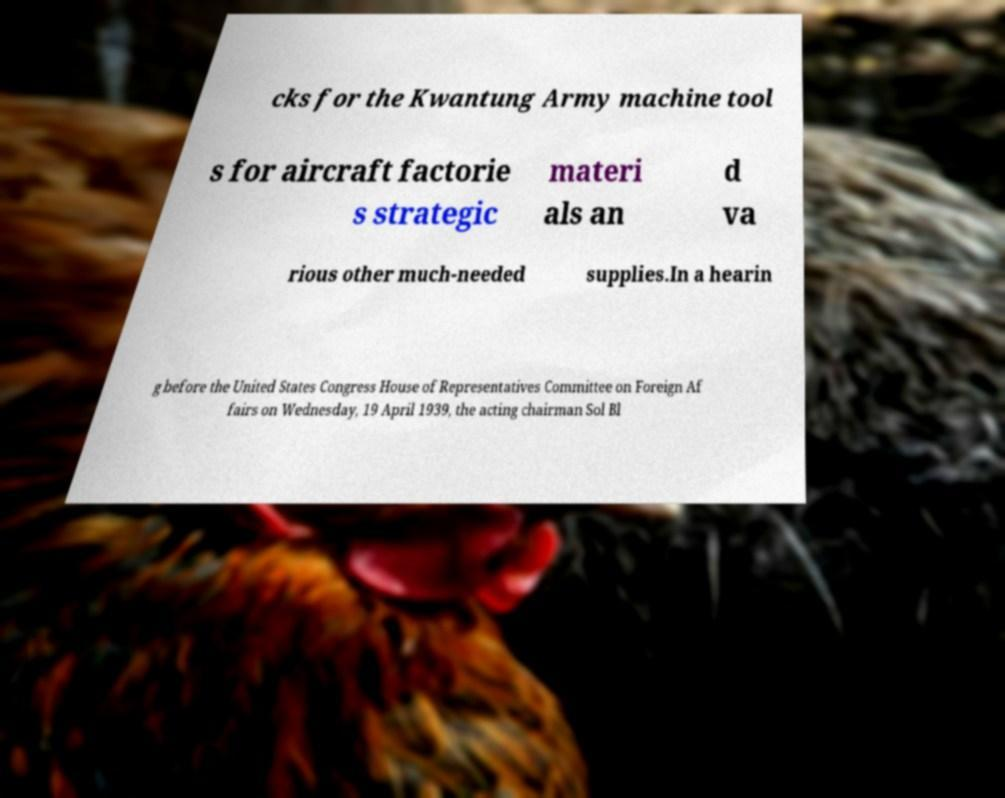Can you read and provide the text displayed in the image?This photo seems to have some interesting text. Can you extract and type it out for me? cks for the Kwantung Army machine tool s for aircraft factorie s strategic materi als an d va rious other much-needed supplies.In a hearin g before the United States Congress House of Representatives Committee on Foreign Af fairs on Wednesday, 19 April 1939, the acting chairman Sol Bl 